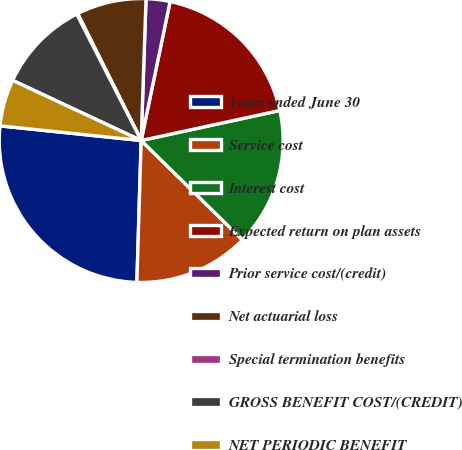Convert chart to OTSL. <chart><loc_0><loc_0><loc_500><loc_500><pie_chart><fcel>Years ended June 30<fcel>Service cost<fcel>Interest cost<fcel>Expected return on plan assets<fcel>Prior service cost/(credit)<fcel>Net actuarial loss<fcel>Special termination benefits<fcel>GROSS BENEFIT COST/(CREDIT)<fcel>NET PERIODIC BENEFIT<nl><fcel>26.16%<fcel>13.14%<fcel>15.74%<fcel>18.34%<fcel>2.72%<fcel>7.93%<fcel>0.12%<fcel>10.53%<fcel>5.32%<nl></chart> 